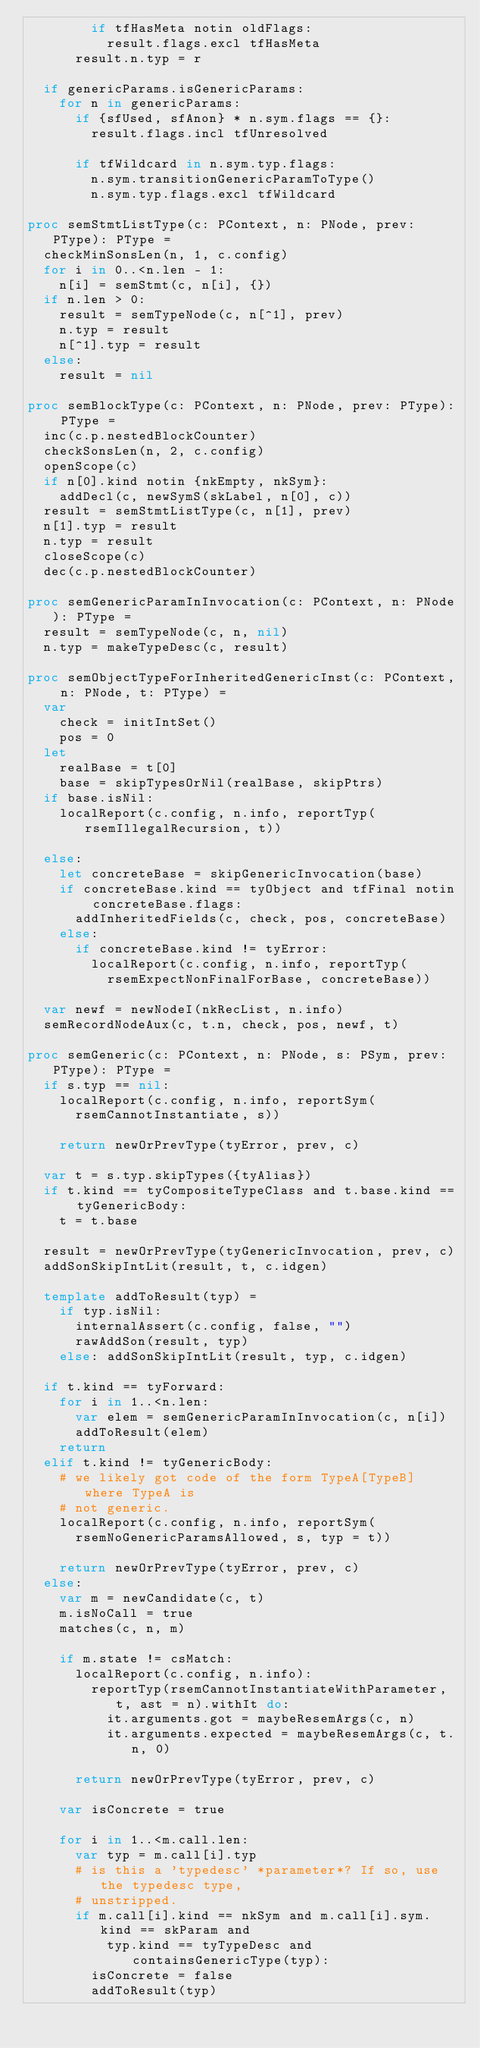<code> <loc_0><loc_0><loc_500><loc_500><_Nim_>        if tfHasMeta notin oldFlags:
          result.flags.excl tfHasMeta
      result.n.typ = r

  if genericParams.isGenericParams:
    for n in genericParams:
      if {sfUsed, sfAnon} * n.sym.flags == {}:
        result.flags.incl tfUnresolved

      if tfWildcard in n.sym.typ.flags:
        n.sym.transitionGenericParamToType()
        n.sym.typ.flags.excl tfWildcard

proc semStmtListType(c: PContext, n: PNode, prev: PType): PType =
  checkMinSonsLen(n, 1, c.config)
  for i in 0..<n.len - 1:
    n[i] = semStmt(c, n[i], {})
  if n.len > 0:
    result = semTypeNode(c, n[^1], prev)
    n.typ = result
    n[^1].typ = result
  else:
    result = nil

proc semBlockType(c: PContext, n: PNode, prev: PType): PType =
  inc(c.p.nestedBlockCounter)
  checkSonsLen(n, 2, c.config)
  openScope(c)
  if n[0].kind notin {nkEmpty, nkSym}:
    addDecl(c, newSymS(skLabel, n[0], c))
  result = semStmtListType(c, n[1], prev)
  n[1].typ = result
  n.typ = result
  closeScope(c)
  dec(c.p.nestedBlockCounter)

proc semGenericParamInInvocation(c: PContext, n: PNode): PType =
  result = semTypeNode(c, n, nil)
  n.typ = makeTypeDesc(c, result)

proc semObjectTypeForInheritedGenericInst(c: PContext, n: PNode, t: PType) =
  var
    check = initIntSet()
    pos = 0
  let
    realBase = t[0]
    base = skipTypesOrNil(realBase, skipPtrs)
  if base.isNil:
    localReport(c.config, n.info, reportTyp(rsemIllegalRecursion, t))

  else:
    let concreteBase = skipGenericInvocation(base)
    if concreteBase.kind == tyObject and tfFinal notin concreteBase.flags:
      addInheritedFields(c, check, pos, concreteBase)
    else:
      if concreteBase.kind != tyError:
        localReport(c.config, n.info, reportTyp(
          rsemExpectNonFinalForBase, concreteBase))

  var newf = newNodeI(nkRecList, n.info)
  semRecordNodeAux(c, t.n, check, pos, newf, t)

proc semGeneric(c: PContext, n: PNode, s: PSym, prev: PType): PType =
  if s.typ == nil:
    localReport(c.config, n.info, reportSym(
      rsemCannotInstantiate, s))

    return newOrPrevType(tyError, prev, c)

  var t = s.typ.skipTypes({tyAlias})
  if t.kind == tyCompositeTypeClass and t.base.kind == tyGenericBody:
    t = t.base

  result = newOrPrevType(tyGenericInvocation, prev, c)
  addSonSkipIntLit(result, t, c.idgen)

  template addToResult(typ) =
    if typ.isNil:
      internalAssert(c.config, false, "")
      rawAddSon(result, typ)
    else: addSonSkipIntLit(result, typ, c.idgen)

  if t.kind == tyForward:
    for i in 1..<n.len:
      var elem = semGenericParamInInvocation(c, n[i])
      addToResult(elem)
    return
  elif t.kind != tyGenericBody:
    # we likely got code of the form TypeA[TypeB] where TypeA is
    # not generic.
    localReport(c.config, n.info, reportSym(
      rsemNoGenericParamsAllowed, s, typ = t))

    return newOrPrevType(tyError, prev, c)
  else:
    var m = newCandidate(c, t)
    m.isNoCall = true
    matches(c, n, m)

    if m.state != csMatch:
      localReport(c.config, n.info):
        reportTyp(rsemCannotInstantiateWithParameter, t, ast = n).withIt do:
          it.arguments.got = maybeResemArgs(c, n)
          it.arguments.expected = maybeResemArgs(c, t.n, 0)

      return newOrPrevType(tyError, prev, c)

    var isConcrete = true

    for i in 1..<m.call.len:
      var typ = m.call[i].typ
      # is this a 'typedesc' *parameter*? If so, use the typedesc type,
      # unstripped.
      if m.call[i].kind == nkSym and m.call[i].sym.kind == skParam and
          typ.kind == tyTypeDesc and containsGenericType(typ):
        isConcrete = false
        addToResult(typ)</code> 